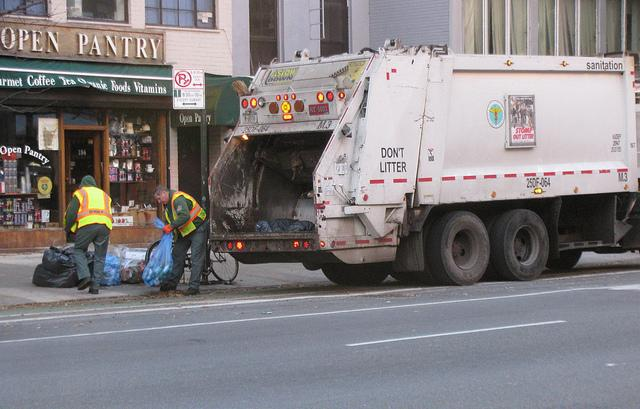Why are the men's vests yellow in color? Please explain your reasoning. visibility. Garbage men are wearing brightly colored vests. roadworkers wear brightly colored clothes to increase visibility and safety. 